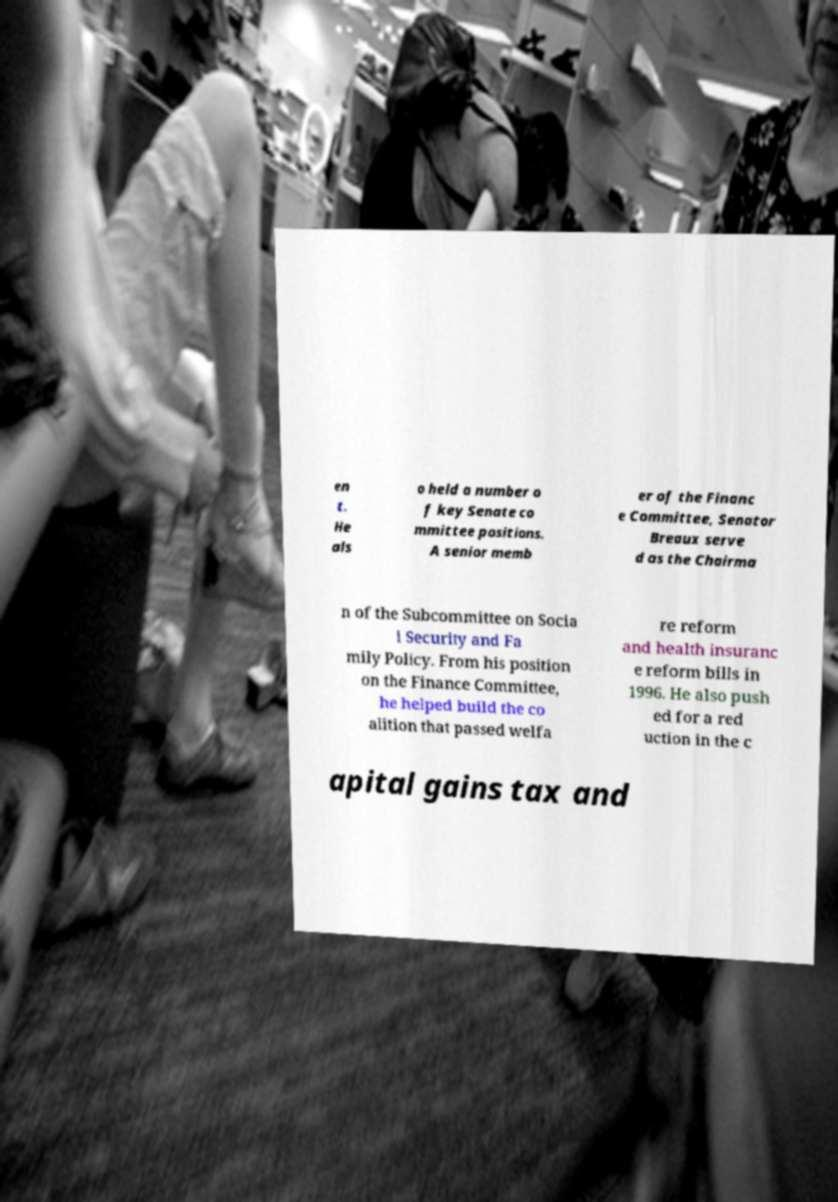For documentation purposes, I need the text within this image transcribed. Could you provide that? en t. He als o held a number o f key Senate co mmittee positions. A senior memb er of the Financ e Committee, Senator Breaux serve d as the Chairma n of the Subcommittee on Socia l Security and Fa mily Policy. From his position on the Finance Committee, he helped build the co alition that passed welfa re reform and health insuranc e reform bills in 1996. He also push ed for a red uction in the c apital gains tax and 